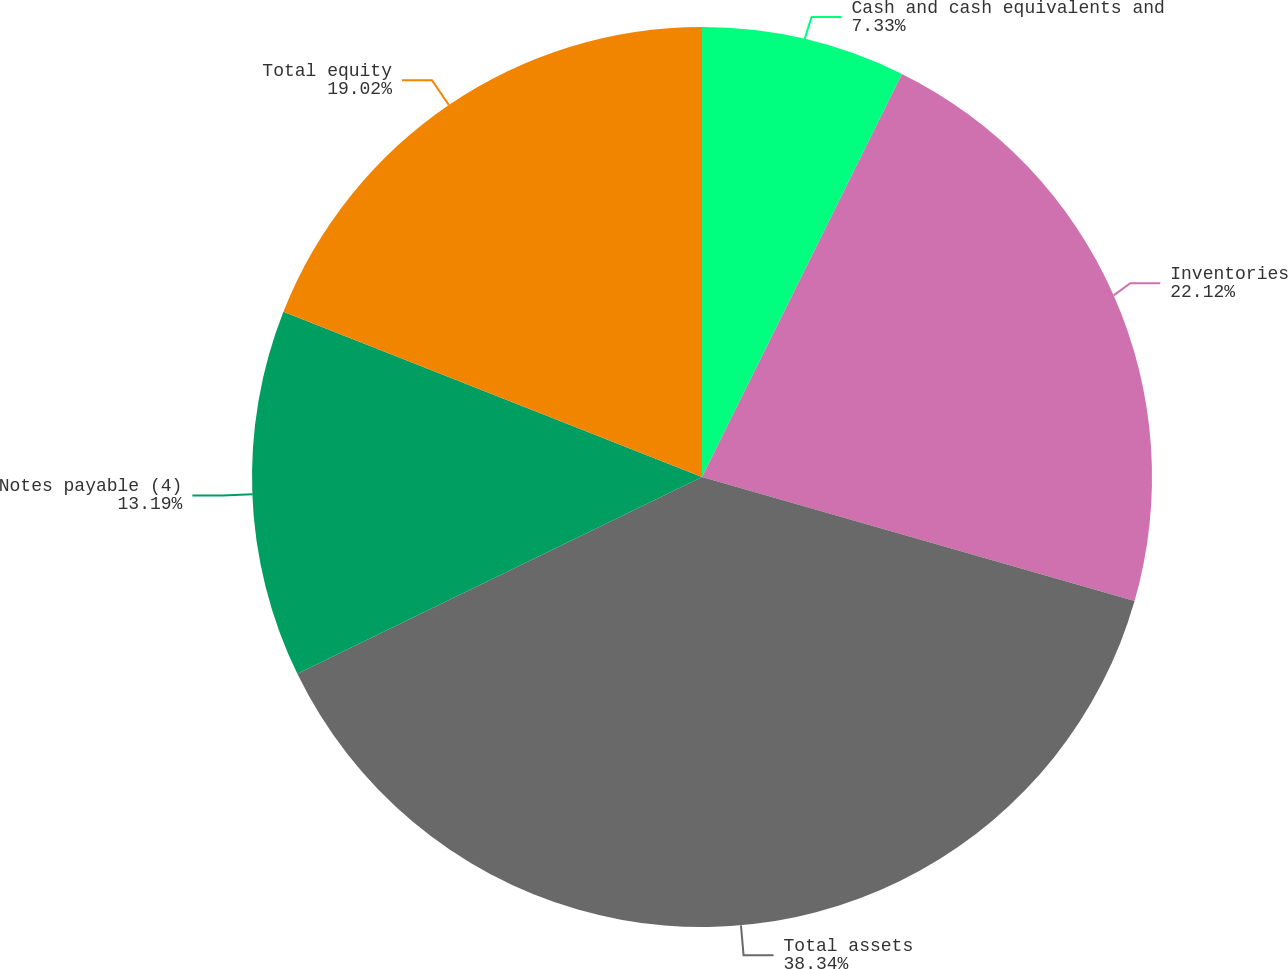<chart> <loc_0><loc_0><loc_500><loc_500><pie_chart><fcel>Cash and cash equivalents and<fcel>Inventories<fcel>Total assets<fcel>Notes payable (4)<fcel>Total equity<nl><fcel>7.33%<fcel>22.12%<fcel>38.35%<fcel>13.19%<fcel>19.02%<nl></chart> 